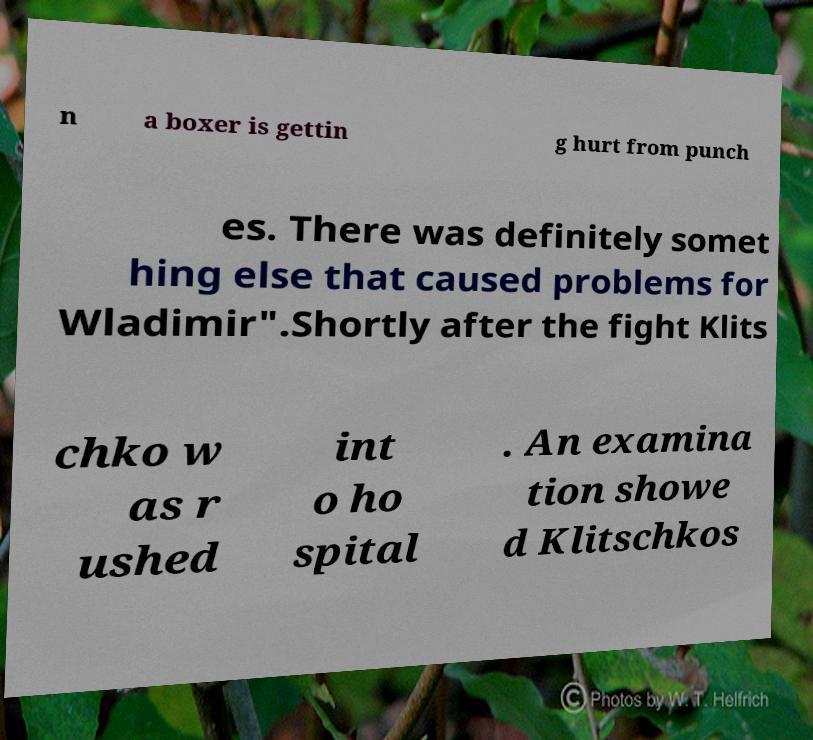Could you extract and type out the text from this image? n a boxer is gettin g hurt from punch es. There was definitely somet hing else that caused problems for Wladimir".Shortly after the fight Klits chko w as r ushed int o ho spital . An examina tion showe d Klitschkos 